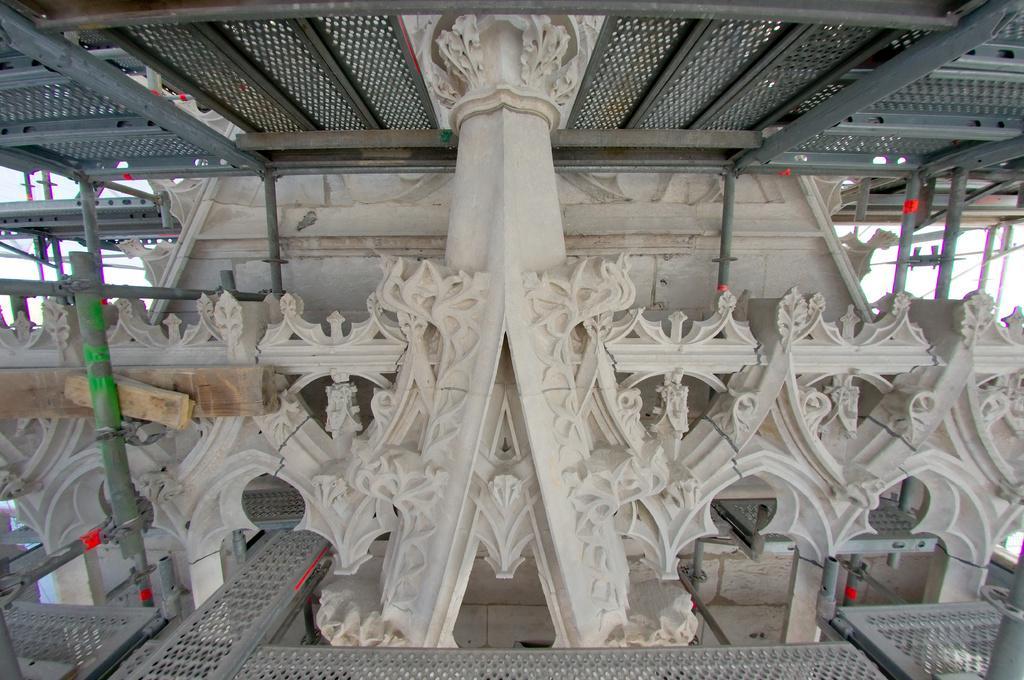Could you give a brief overview of what you see in this image? In this image we can see some plywood and poles, at the top of the roof we can see some metal rods. 